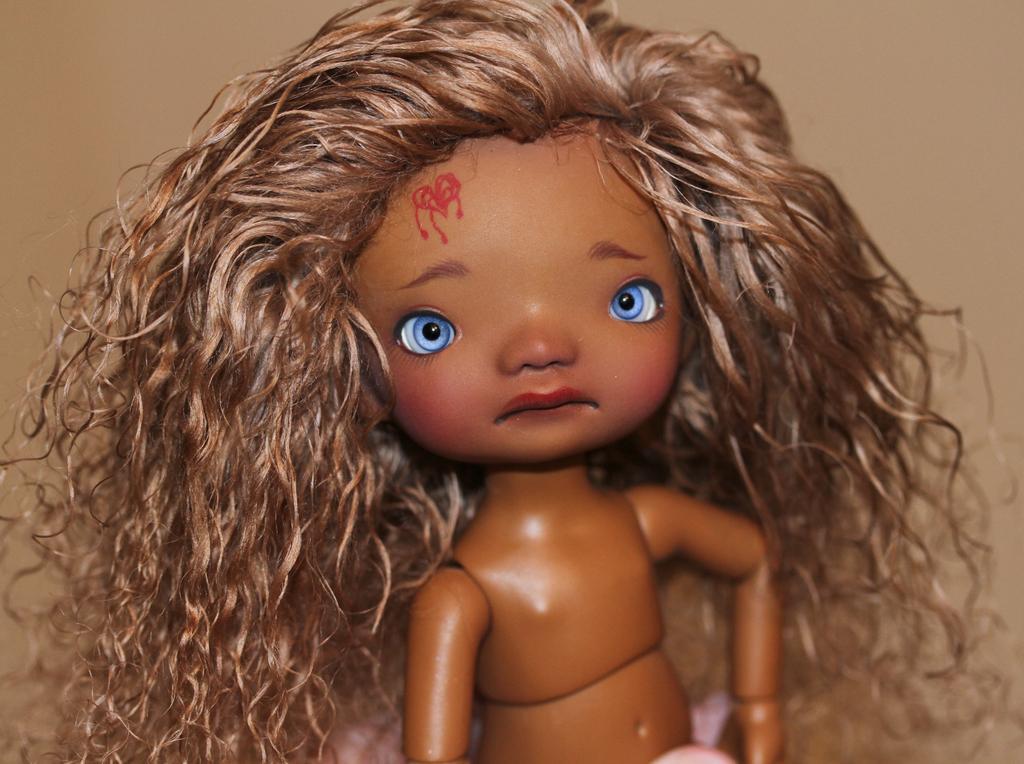Can you describe this image briefly? In this image we can see a doll 